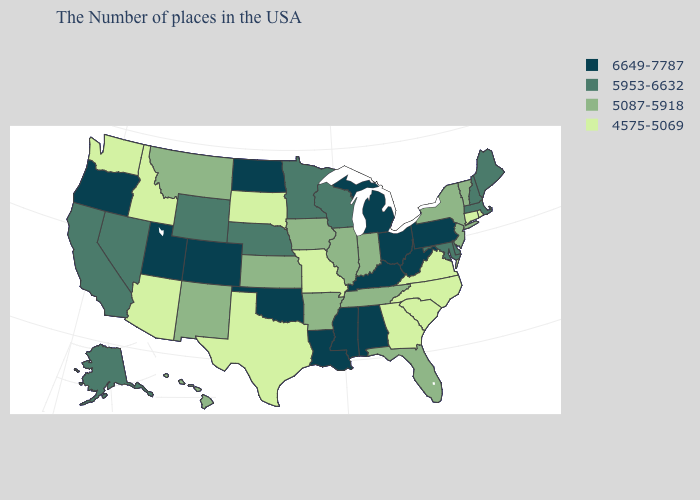Does Oregon have the highest value in the West?
Write a very short answer. Yes. What is the value of Connecticut?
Give a very brief answer. 4575-5069. Does South Dakota have a lower value than North Dakota?
Write a very short answer. Yes. Name the states that have a value in the range 5087-5918?
Keep it brief. Vermont, New York, New Jersey, Florida, Indiana, Tennessee, Illinois, Arkansas, Iowa, Kansas, New Mexico, Montana, Hawaii. Among the states that border Arizona , does Colorado have the highest value?
Answer briefly. Yes. Name the states that have a value in the range 5087-5918?
Answer briefly. Vermont, New York, New Jersey, Florida, Indiana, Tennessee, Illinois, Arkansas, Iowa, Kansas, New Mexico, Montana, Hawaii. What is the highest value in states that border Indiana?
Give a very brief answer. 6649-7787. What is the value of Wisconsin?
Short answer required. 5953-6632. Which states have the highest value in the USA?
Quick response, please. Pennsylvania, West Virginia, Ohio, Michigan, Kentucky, Alabama, Mississippi, Louisiana, Oklahoma, North Dakota, Colorado, Utah, Oregon. What is the value of Pennsylvania?
Answer briefly. 6649-7787. Among the states that border Virginia , does North Carolina have the lowest value?
Be succinct. Yes. How many symbols are there in the legend?
Write a very short answer. 4. Does the map have missing data?
Keep it brief. No. What is the highest value in the MidWest ?
Concise answer only. 6649-7787. What is the value of Kentucky?
Give a very brief answer. 6649-7787. 